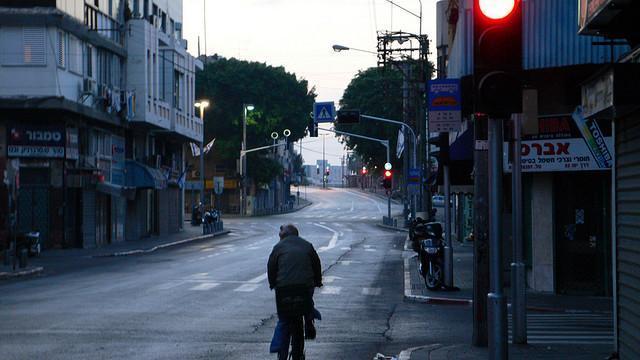How many people are using the road?
Give a very brief answer. 1. How many people can be seen?
Give a very brief answer. 1. 